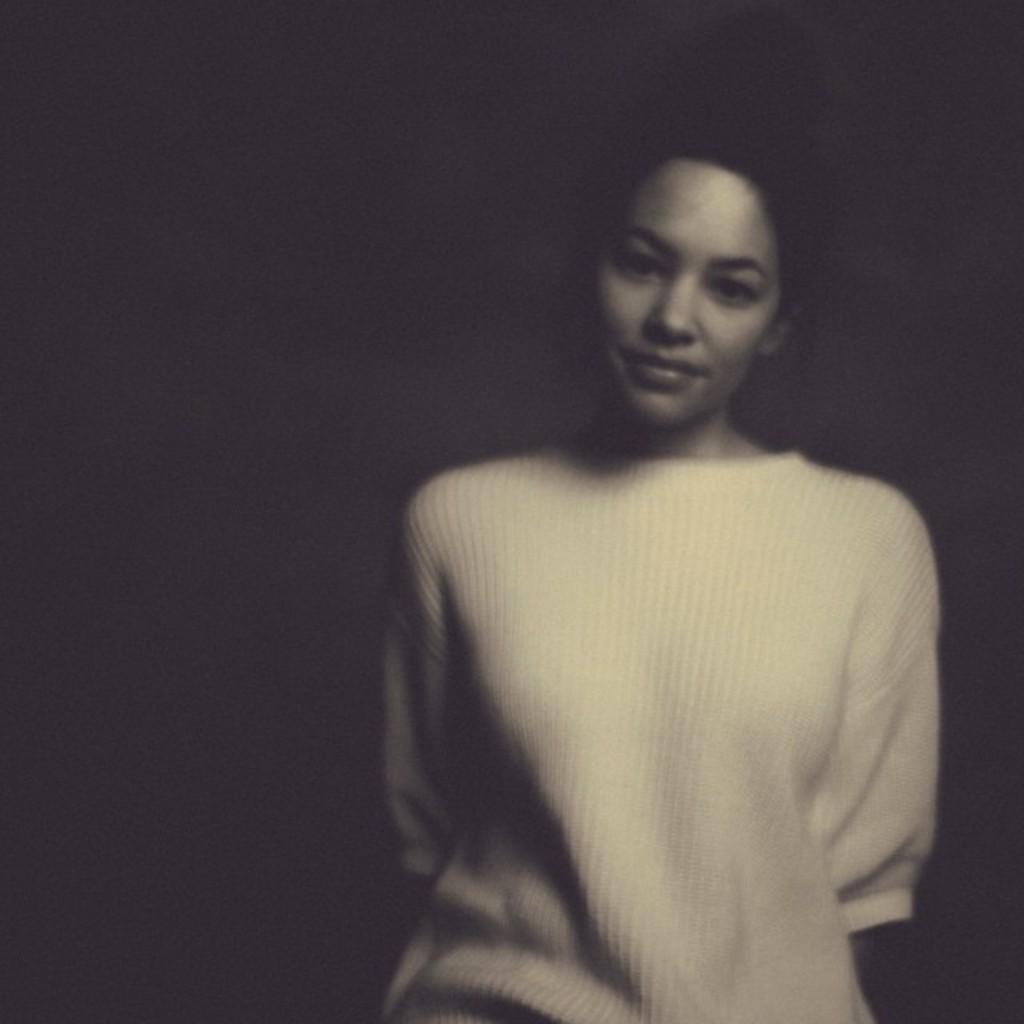Who is present in the image? There is a woman in the image. What is the woman doing in the image? The woman is standing. What type of wine is the woman holding in the image? There is no wine present in the image; the woman is simply standing. What is the woman's elbow doing in the image? The elbow is not mentioned in the provided facts, and there is no indication of its position or action in the image. 